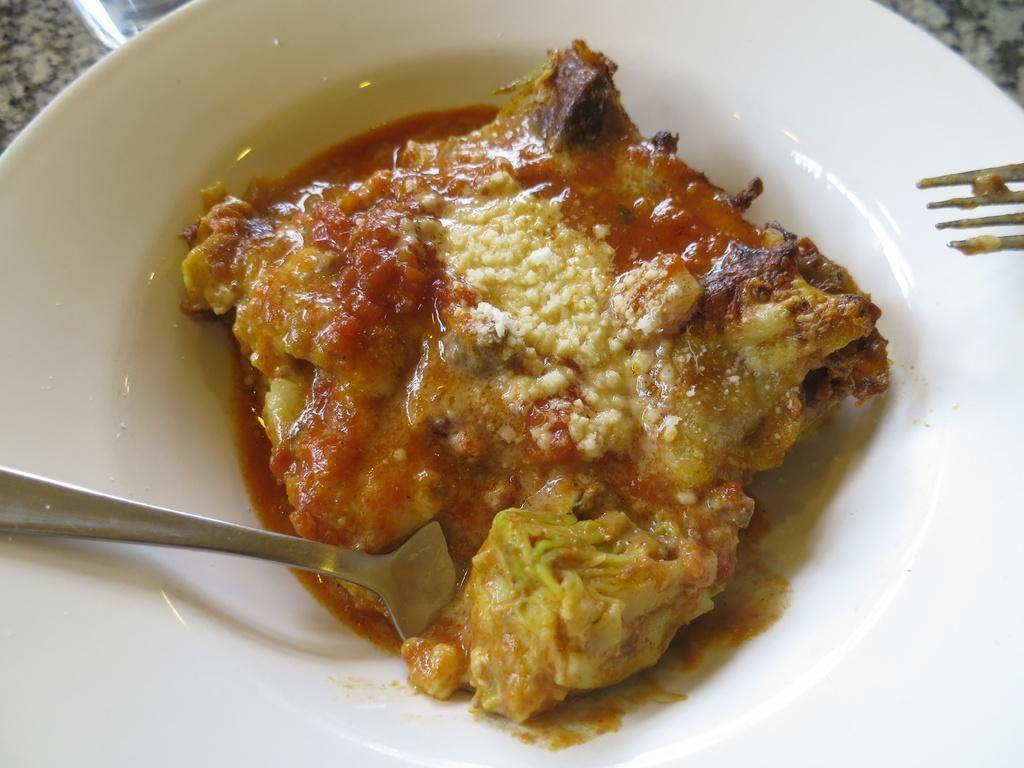What type of objects can be seen in the image? There are food items and spoons in the image. Where are the food items and spoons located? The food items and spoons are on a plate. What is the surface beneath the plate? The plate is placed on a granite surface. Can you see a lake in the image? No, there is no lake present in the image. Is anyone kicking the food items in the image? No, there is no one kicking the food items in the image. 